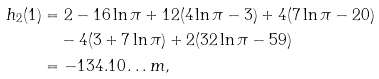Convert formula to latex. <formula><loc_0><loc_0><loc_500><loc_500>h _ { 2 } ( 1 ) & = 2 - 1 6 \ln \pi + 1 2 ( 4 \ln \pi - 3 ) + 4 ( 7 \ln \pi - 2 0 ) \\ & \quad - 4 ( 3 + 7 \ln \pi ) + 2 ( 3 2 \ln \pi - 5 9 ) \\ & = - 1 3 4 . 1 0 \dots m ,</formula> 